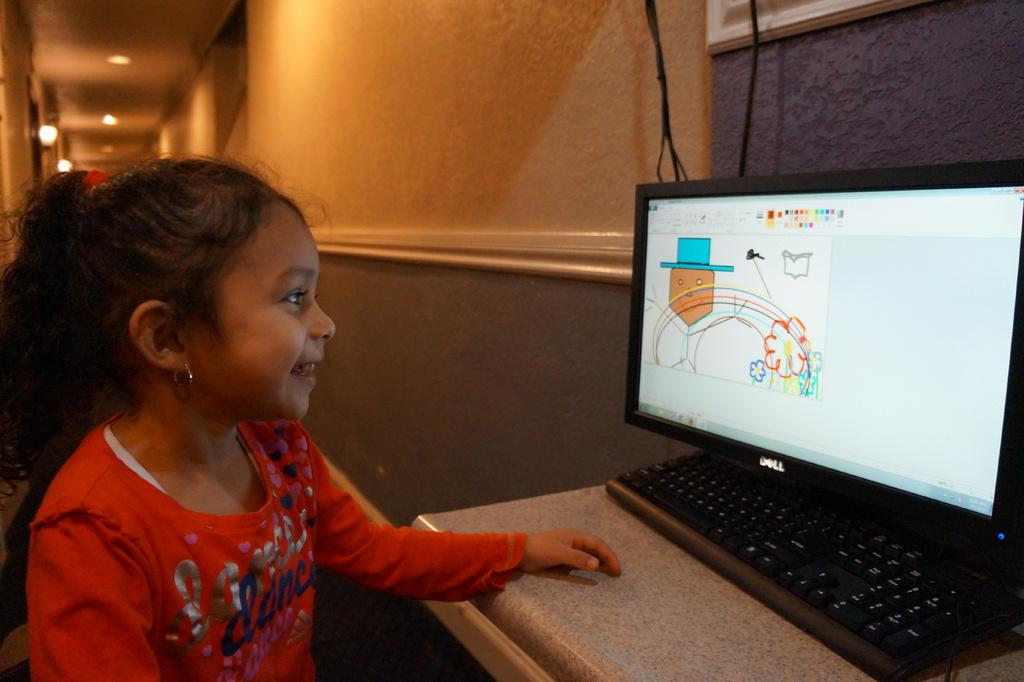<image>
Render a clear and concise summary of the photo. A girl wearing a red shirt that has blue hearts and the word dance on it sits in front of a computer screen showing a drawing app 